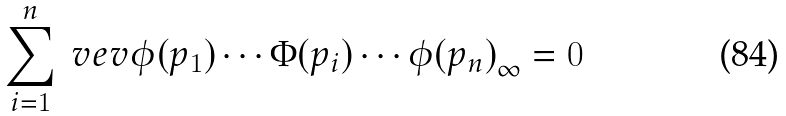Convert formula to latex. <formula><loc_0><loc_0><loc_500><loc_500>\sum _ { i = 1 } ^ { n } \ v e v { \phi ( p _ { 1 } ) \cdots \Phi ( p _ { i } ) \cdots \phi ( p _ { n } ) } _ { \infty } = 0</formula> 